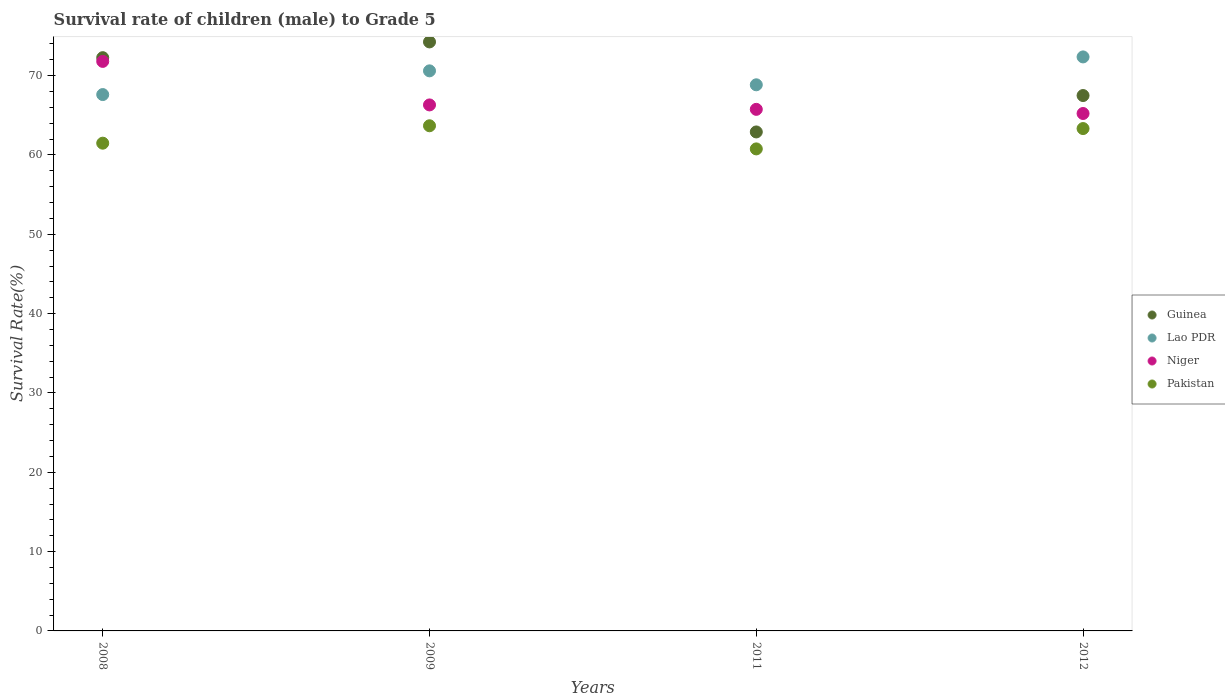What is the survival rate of male children to grade 5 in Lao PDR in 2009?
Provide a short and direct response. 70.61. Across all years, what is the maximum survival rate of male children to grade 5 in Pakistan?
Offer a terse response. 63.68. Across all years, what is the minimum survival rate of male children to grade 5 in Guinea?
Your response must be concise. 62.9. In which year was the survival rate of male children to grade 5 in Lao PDR minimum?
Give a very brief answer. 2008. What is the total survival rate of male children to grade 5 in Pakistan in the graph?
Offer a terse response. 249.27. What is the difference between the survival rate of male children to grade 5 in Niger in 2011 and that in 2012?
Give a very brief answer. 0.52. What is the difference between the survival rate of male children to grade 5 in Niger in 2009 and the survival rate of male children to grade 5 in Lao PDR in 2012?
Give a very brief answer. -6.05. What is the average survival rate of male children to grade 5 in Guinea per year?
Offer a terse response. 69.23. In the year 2008, what is the difference between the survival rate of male children to grade 5 in Guinea and survival rate of male children to grade 5 in Niger?
Keep it short and to the point. 0.47. In how many years, is the survival rate of male children to grade 5 in Niger greater than 72 %?
Your response must be concise. 0. What is the ratio of the survival rate of male children to grade 5 in Guinea in 2011 to that in 2012?
Give a very brief answer. 0.93. Is the survival rate of male children to grade 5 in Guinea in 2009 less than that in 2011?
Provide a succinct answer. No. What is the difference between the highest and the second highest survival rate of male children to grade 5 in Pakistan?
Make the answer very short. 0.35. What is the difference between the highest and the lowest survival rate of male children to grade 5 in Guinea?
Ensure brevity in your answer.  11.35. Is the sum of the survival rate of male children to grade 5 in Pakistan in 2008 and 2011 greater than the maximum survival rate of male children to grade 5 in Niger across all years?
Offer a terse response. Yes. Is it the case that in every year, the sum of the survival rate of male children to grade 5 in Lao PDR and survival rate of male children to grade 5 in Niger  is greater than the sum of survival rate of male children to grade 5 in Pakistan and survival rate of male children to grade 5 in Guinea?
Give a very brief answer. Yes. Is the survival rate of male children to grade 5 in Guinea strictly greater than the survival rate of male children to grade 5 in Lao PDR over the years?
Make the answer very short. No. Is the survival rate of male children to grade 5 in Niger strictly less than the survival rate of male children to grade 5 in Guinea over the years?
Provide a succinct answer. No. How many dotlines are there?
Keep it short and to the point. 4. How many years are there in the graph?
Offer a very short reply. 4. How many legend labels are there?
Ensure brevity in your answer.  4. How are the legend labels stacked?
Keep it short and to the point. Vertical. What is the title of the graph?
Ensure brevity in your answer.  Survival rate of children (male) to Grade 5. What is the label or title of the Y-axis?
Offer a terse response. Survival Rate(%). What is the Survival Rate(%) in Guinea in 2008?
Make the answer very short. 72.27. What is the Survival Rate(%) of Lao PDR in 2008?
Make the answer very short. 67.62. What is the Survival Rate(%) in Niger in 2008?
Offer a terse response. 71.8. What is the Survival Rate(%) in Pakistan in 2008?
Make the answer very short. 61.49. What is the Survival Rate(%) of Guinea in 2009?
Keep it short and to the point. 74.25. What is the Survival Rate(%) of Lao PDR in 2009?
Your answer should be very brief. 70.61. What is the Survival Rate(%) of Niger in 2009?
Offer a terse response. 66.31. What is the Survival Rate(%) of Pakistan in 2009?
Provide a short and direct response. 63.68. What is the Survival Rate(%) in Guinea in 2011?
Make the answer very short. 62.9. What is the Survival Rate(%) of Lao PDR in 2011?
Give a very brief answer. 68.85. What is the Survival Rate(%) of Niger in 2011?
Make the answer very short. 65.75. What is the Survival Rate(%) in Pakistan in 2011?
Your response must be concise. 60.77. What is the Survival Rate(%) of Guinea in 2012?
Your answer should be very brief. 67.49. What is the Survival Rate(%) in Lao PDR in 2012?
Your answer should be compact. 72.36. What is the Survival Rate(%) of Niger in 2012?
Keep it short and to the point. 65.23. What is the Survival Rate(%) of Pakistan in 2012?
Offer a terse response. 63.33. Across all years, what is the maximum Survival Rate(%) in Guinea?
Provide a succinct answer. 74.25. Across all years, what is the maximum Survival Rate(%) of Lao PDR?
Offer a terse response. 72.36. Across all years, what is the maximum Survival Rate(%) of Niger?
Keep it short and to the point. 71.8. Across all years, what is the maximum Survival Rate(%) in Pakistan?
Your response must be concise. 63.68. Across all years, what is the minimum Survival Rate(%) of Guinea?
Keep it short and to the point. 62.9. Across all years, what is the minimum Survival Rate(%) in Lao PDR?
Offer a terse response. 67.62. Across all years, what is the minimum Survival Rate(%) in Niger?
Ensure brevity in your answer.  65.23. Across all years, what is the minimum Survival Rate(%) of Pakistan?
Your response must be concise. 60.77. What is the total Survival Rate(%) in Guinea in the graph?
Give a very brief answer. 276.92. What is the total Survival Rate(%) in Lao PDR in the graph?
Offer a terse response. 279.43. What is the total Survival Rate(%) in Niger in the graph?
Your answer should be very brief. 269.09. What is the total Survival Rate(%) of Pakistan in the graph?
Ensure brevity in your answer.  249.27. What is the difference between the Survival Rate(%) of Guinea in 2008 and that in 2009?
Your answer should be very brief. -1.99. What is the difference between the Survival Rate(%) of Lao PDR in 2008 and that in 2009?
Keep it short and to the point. -2.99. What is the difference between the Survival Rate(%) of Niger in 2008 and that in 2009?
Your response must be concise. 5.49. What is the difference between the Survival Rate(%) of Pakistan in 2008 and that in 2009?
Provide a short and direct response. -2.19. What is the difference between the Survival Rate(%) of Guinea in 2008 and that in 2011?
Give a very brief answer. 9.36. What is the difference between the Survival Rate(%) in Lao PDR in 2008 and that in 2011?
Offer a terse response. -1.23. What is the difference between the Survival Rate(%) in Niger in 2008 and that in 2011?
Keep it short and to the point. 6.05. What is the difference between the Survival Rate(%) of Pakistan in 2008 and that in 2011?
Your answer should be very brief. 0.72. What is the difference between the Survival Rate(%) in Guinea in 2008 and that in 2012?
Ensure brevity in your answer.  4.77. What is the difference between the Survival Rate(%) in Lao PDR in 2008 and that in 2012?
Provide a short and direct response. -4.75. What is the difference between the Survival Rate(%) of Niger in 2008 and that in 2012?
Ensure brevity in your answer.  6.57. What is the difference between the Survival Rate(%) in Pakistan in 2008 and that in 2012?
Keep it short and to the point. -1.84. What is the difference between the Survival Rate(%) in Guinea in 2009 and that in 2011?
Keep it short and to the point. 11.35. What is the difference between the Survival Rate(%) of Lao PDR in 2009 and that in 2011?
Ensure brevity in your answer.  1.76. What is the difference between the Survival Rate(%) of Niger in 2009 and that in 2011?
Your answer should be very brief. 0.56. What is the difference between the Survival Rate(%) in Pakistan in 2009 and that in 2011?
Your answer should be compact. 2.92. What is the difference between the Survival Rate(%) of Guinea in 2009 and that in 2012?
Provide a succinct answer. 6.76. What is the difference between the Survival Rate(%) in Lao PDR in 2009 and that in 2012?
Your response must be concise. -1.76. What is the difference between the Survival Rate(%) of Niger in 2009 and that in 2012?
Keep it short and to the point. 1.08. What is the difference between the Survival Rate(%) of Pakistan in 2009 and that in 2012?
Offer a very short reply. 0.35. What is the difference between the Survival Rate(%) in Guinea in 2011 and that in 2012?
Ensure brevity in your answer.  -4.59. What is the difference between the Survival Rate(%) in Lao PDR in 2011 and that in 2012?
Keep it short and to the point. -3.52. What is the difference between the Survival Rate(%) of Niger in 2011 and that in 2012?
Provide a short and direct response. 0.52. What is the difference between the Survival Rate(%) of Pakistan in 2011 and that in 2012?
Your answer should be compact. -2.56. What is the difference between the Survival Rate(%) of Guinea in 2008 and the Survival Rate(%) of Lao PDR in 2009?
Ensure brevity in your answer.  1.66. What is the difference between the Survival Rate(%) of Guinea in 2008 and the Survival Rate(%) of Niger in 2009?
Your answer should be compact. 5.96. What is the difference between the Survival Rate(%) of Guinea in 2008 and the Survival Rate(%) of Pakistan in 2009?
Your answer should be very brief. 8.58. What is the difference between the Survival Rate(%) of Lao PDR in 2008 and the Survival Rate(%) of Niger in 2009?
Give a very brief answer. 1.31. What is the difference between the Survival Rate(%) of Lao PDR in 2008 and the Survival Rate(%) of Pakistan in 2009?
Offer a very short reply. 3.93. What is the difference between the Survival Rate(%) of Niger in 2008 and the Survival Rate(%) of Pakistan in 2009?
Offer a very short reply. 8.12. What is the difference between the Survival Rate(%) in Guinea in 2008 and the Survival Rate(%) in Lao PDR in 2011?
Provide a succinct answer. 3.42. What is the difference between the Survival Rate(%) of Guinea in 2008 and the Survival Rate(%) of Niger in 2011?
Offer a very short reply. 6.51. What is the difference between the Survival Rate(%) in Guinea in 2008 and the Survival Rate(%) in Pakistan in 2011?
Your response must be concise. 11.5. What is the difference between the Survival Rate(%) in Lao PDR in 2008 and the Survival Rate(%) in Niger in 2011?
Offer a terse response. 1.86. What is the difference between the Survival Rate(%) of Lao PDR in 2008 and the Survival Rate(%) of Pakistan in 2011?
Your response must be concise. 6.85. What is the difference between the Survival Rate(%) in Niger in 2008 and the Survival Rate(%) in Pakistan in 2011?
Your answer should be compact. 11.03. What is the difference between the Survival Rate(%) in Guinea in 2008 and the Survival Rate(%) in Lao PDR in 2012?
Offer a very short reply. -0.1. What is the difference between the Survival Rate(%) of Guinea in 2008 and the Survival Rate(%) of Niger in 2012?
Offer a very short reply. 7.04. What is the difference between the Survival Rate(%) of Guinea in 2008 and the Survival Rate(%) of Pakistan in 2012?
Give a very brief answer. 8.94. What is the difference between the Survival Rate(%) in Lao PDR in 2008 and the Survival Rate(%) in Niger in 2012?
Ensure brevity in your answer.  2.39. What is the difference between the Survival Rate(%) of Lao PDR in 2008 and the Survival Rate(%) of Pakistan in 2012?
Your answer should be compact. 4.29. What is the difference between the Survival Rate(%) in Niger in 2008 and the Survival Rate(%) in Pakistan in 2012?
Your answer should be very brief. 8.47. What is the difference between the Survival Rate(%) of Guinea in 2009 and the Survival Rate(%) of Lao PDR in 2011?
Offer a very short reply. 5.4. What is the difference between the Survival Rate(%) in Guinea in 2009 and the Survival Rate(%) in Niger in 2011?
Offer a terse response. 8.5. What is the difference between the Survival Rate(%) in Guinea in 2009 and the Survival Rate(%) in Pakistan in 2011?
Your answer should be compact. 13.49. What is the difference between the Survival Rate(%) of Lao PDR in 2009 and the Survival Rate(%) of Niger in 2011?
Provide a short and direct response. 4.85. What is the difference between the Survival Rate(%) in Lao PDR in 2009 and the Survival Rate(%) in Pakistan in 2011?
Your answer should be compact. 9.84. What is the difference between the Survival Rate(%) in Niger in 2009 and the Survival Rate(%) in Pakistan in 2011?
Make the answer very short. 5.54. What is the difference between the Survival Rate(%) in Guinea in 2009 and the Survival Rate(%) in Lao PDR in 2012?
Provide a succinct answer. 1.89. What is the difference between the Survival Rate(%) of Guinea in 2009 and the Survival Rate(%) of Niger in 2012?
Your response must be concise. 9.02. What is the difference between the Survival Rate(%) of Guinea in 2009 and the Survival Rate(%) of Pakistan in 2012?
Make the answer very short. 10.92. What is the difference between the Survival Rate(%) in Lao PDR in 2009 and the Survival Rate(%) in Niger in 2012?
Make the answer very short. 5.38. What is the difference between the Survival Rate(%) in Lao PDR in 2009 and the Survival Rate(%) in Pakistan in 2012?
Provide a short and direct response. 7.28. What is the difference between the Survival Rate(%) in Niger in 2009 and the Survival Rate(%) in Pakistan in 2012?
Keep it short and to the point. 2.98. What is the difference between the Survival Rate(%) in Guinea in 2011 and the Survival Rate(%) in Lao PDR in 2012?
Your response must be concise. -9.46. What is the difference between the Survival Rate(%) in Guinea in 2011 and the Survival Rate(%) in Niger in 2012?
Provide a short and direct response. -2.32. What is the difference between the Survival Rate(%) of Guinea in 2011 and the Survival Rate(%) of Pakistan in 2012?
Give a very brief answer. -0.43. What is the difference between the Survival Rate(%) in Lao PDR in 2011 and the Survival Rate(%) in Niger in 2012?
Your answer should be compact. 3.62. What is the difference between the Survival Rate(%) in Lao PDR in 2011 and the Survival Rate(%) in Pakistan in 2012?
Give a very brief answer. 5.52. What is the difference between the Survival Rate(%) in Niger in 2011 and the Survival Rate(%) in Pakistan in 2012?
Give a very brief answer. 2.42. What is the average Survival Rate(%) in Guinea per year?
Make the answer very short. 69.23. What is the average Survival Rate(%) in Lao PDR per year?
Give a very brief answer. 69.86. What is the average Survival Rate(%) of Niger per year?
Offer a very short reply. 67.27. What is the average Survival Rate(%) of Pakistan per year?
Your answer should be very brief. 62.32. In the year 2008, what is the difference between the Survival Rate(%) of Guinea and Survival Rate(%) of Lao PDR?
Provide a short and direct response. 4.65. In the year 2008, what is the difference between the Survival Rate(%) in Guinea and Survival Rate(%) in Niger?
Make the answer very short. 0.47. In the year 2008, what is the difference between the Survival Rate(%) in Guinea and Survival Rate(%) in Pakistan?
Provide a succinct answer. 10.78. In the year 2008, what is the difference between the Survival Rate(%) of Lao PDR and Survival Rate(%) of Niger?
Your answer should be very brief. -4.18. In the year 2008, what is the difference between the Survival Rate(%) of Lao PDR and Survival Rate(%) of Pakistan?
Keep it short and to the point. 6.13. In the year 2008, what is the difference between the Survival Rate(%) in Niger and Survival Rate(%) in Pakistan?
Make the answer very short. 10.31. In the year 2009, what is the difference between the Survival Rate(%) of Guinea and Survival Rate(%) of Lao PDR?
Ensure brevity in your answer.  3.65. In the year 2009, what is the difference between the Survival Rate(%) of Guinea and Survival Rate(%) of Niger?
Your answer should be compact. 7.94. In the year 2009, what is the difference between the Survival Rate(%) in Guinea and Survival Rate(%) in Pakistan?
Provide a succinct answer. 10.57. In the year 2009, what is the difference between the Survival Rate(%) of Lao PDR and Survival Rate(%) of Niger?
Offer a very short reply. 4.3. In the year 2009, what is the difference between the Survival Rate(%) of Lao PDR and Survival Rate(%) of Pakistan?
Provide a succinct answer. 6.92. In the year 2009, what is the difference between the Survival Rate(%) of Niger and Survival Rate(%) of Pakistan?
Provide a succinct answer. 2.63. In the year 2011, what is the difference between the Survival Rate(%) of Guinea and Survival Rate(%) of Lao PDR?
Ensure brevity in your answer.  -5.94. In the year 2011, what is the difference between the Survival Rate(%) in Guinea and Survival Rate(%) in Niger?
Keep it short and to the point. -2.85. In the year 2011, what is the difference between the Survival Rate(%) of Guinea and Survival Rate(%) of Pakistan?
Offer a terse response. 2.14. In the year 2011, what is the difference between the Survival Rate(%) in Lao PDR and Survival Rate(%) in Niger?
Provide a short and direct response. 3.09. In the year 2011, what is the difference between the Survival Rate(%) of Lao PDR and Survival Rate(%) of Pakistan?
Your answer should be very brief. 8.08. In the year 2011, what is the difference between the Survival Rate(%) in Niger and Survival Rate(%) in Pakistan?
Provide a succinct answer. 4.99. In the year 2012, what is the difference between the Survival Rate(%) of Guinea and Survival Rate(%) of Lao PDR?
Ensure brevity in your answer.  -4.87. In the year 2012, what is the difference between the Survival Rate(%) of Guinea and Survival Rate(%) of Niger?
Provide a short and direct response. 2.26. In the year 2012, what is the difference between the Survival Rate(%) of Guinea and Survival Rate(%) of Pakistan?
Provide a succinct answer. 4.16. In the year 2012, what is the difference between the Survival Rate(%) of Lao PDR and Survival Rate(%) of Niger?
Offer a very short reply. 7.13. In the year 2012, what is the difference between the Survival Rate(%) in Lao PDR and Survival Rate(%) in Pakistan?
Keep it short and to the point. 9.03. In the year 2012, what is the difference between the Survival Rate(%) in Niger and Survival Rate(%) in Pakistan?
Keep it short and to the point. 1.9. What is the ratio of the Survival Rate(%) of Guinea in 2008 to that in 2009?
Your answer should be very brief. 0.97. What is the ratio of the Survival Rate(%) in Lao PDR in 2008 to that in 2009?
Your answer should be compact. 0.96. What is the ratio of the Survival Rate(%) of Niger in 2008 to that in 2009?
Offer a very short reply. 1.08. What is the ratio of the Survival Rate(%) of Pakistan in 2008 to that in 2009?
Give a very brief answer. 0.97. What is the ratio of the Survival Rate(%) in Guinea in 2008 to that in 2011?
Provide a succinct answer. 1.15. What is the ratio of the Survival Rate(%) in Lao PDR in 2008 to that in 2011?
Provide a succinct answer. 0.98. What is the ratio of the Survival Rate(%) in Niger in 2008 to that in 2011?
Offer a terse response. 1.09. What is the ratio of the Survival Rate(%) of Pakistan in 2008 to that in 2011?
Offer a very short reply. 1.01. What is the ratio of the Survival Rate(%) of Guinea in 2008 to that in 2012?
Give a very brief answer. 1.07. What is the ratio of the Survival Rate(%) of Lao PDR in 2008 to that in 2012?
Your answer should be very brief. 0.93. What is the ratio of the Survival Rate(%) in Niger in 2008 to that in 2012?
Offer a terse response. 1.1. What is the ratio of the Survival Rate(%) of Pakistan in 2008 to that in 2012?
Make the answer very short. 0.97. What is the ratio of the Survival Rate(%) of Guinea in 2009 to that in 2011?
Ensure brevity in your answer.  1.18. What is the ratio of the Survival Rate(%) in Lao PDR in 2009 to that in 2011?
Your response must be concise. 1.03. What is the ratio of the Survival Rate(%) of Niger in 2009 to that in 2011?
Offer a terse response. 1.01. What is the ratio of the Survival Rate(%) of Pakistan in 2009 to that in 2011?
Your response must be concise. 1.05. What is the ratio of the Survival Rate(%) of Guinea in 2009 to that in 2012?
Your answer should be very brief. 1.1. What is the ratio of the Survival Rate(%) in Lao PDR in 2009 to that in 2012?
Provide a succinct answer. 0.98. What is the ratio of the Survival Rate(%) of Niger in 2009 to that in 2012?
Your response must be concise. 1.02. What is the ratio of the Survival Rate(%) in Pakistan in 2009 to that in 2012?
Keep it short and to the point. 1.01. What is the ratio of the Survival Rate(%) in Guinea in 2011 to that in 2012?
Provide a short and direct response. 0.93. What is the ratio of the Survival Rate(%) in Lao PDR in 2011 to that in 2012?
Provide a short and direct response. 0.95. What is the ratio of the Survival Rate(%) in Pakistan in 2011 to that in 2012?
Your answer should be compact. 0.96. What is the difference between the highest and the second highest Survival Rate(%) in Guinea?
Provide a short and direct response. 1.99. What is the difference between the highest and the second highest Survival Rate(%) in Lao PDR?
Ensure brevity in your answer.  1.76. What is the difference between the highest and the second highest Survival Rate(%) of Niger?
Your answer should be very brief. 5.49. What is the difference between the highest and the second highest Survival Rate(%) in Pakistan?
Offer a very short reply. 0.35. What is the difference between the highest and the lowest Survival Rate(%) of Guinea?
Provide a succinct answer. 11.35. What is the difference between the highest and the lowest Survival Rate(%) of Lao PDR?
Provide a succinct answer. 4.75. What is the difference between the highest and the lowest Survival Rate(%) in Niger?
Provide a short and direct response. 6.57. What is the difference between the highest and the lowest Survival Rate(%) of Pakistan?
Your answer should be compact. 2.92. 